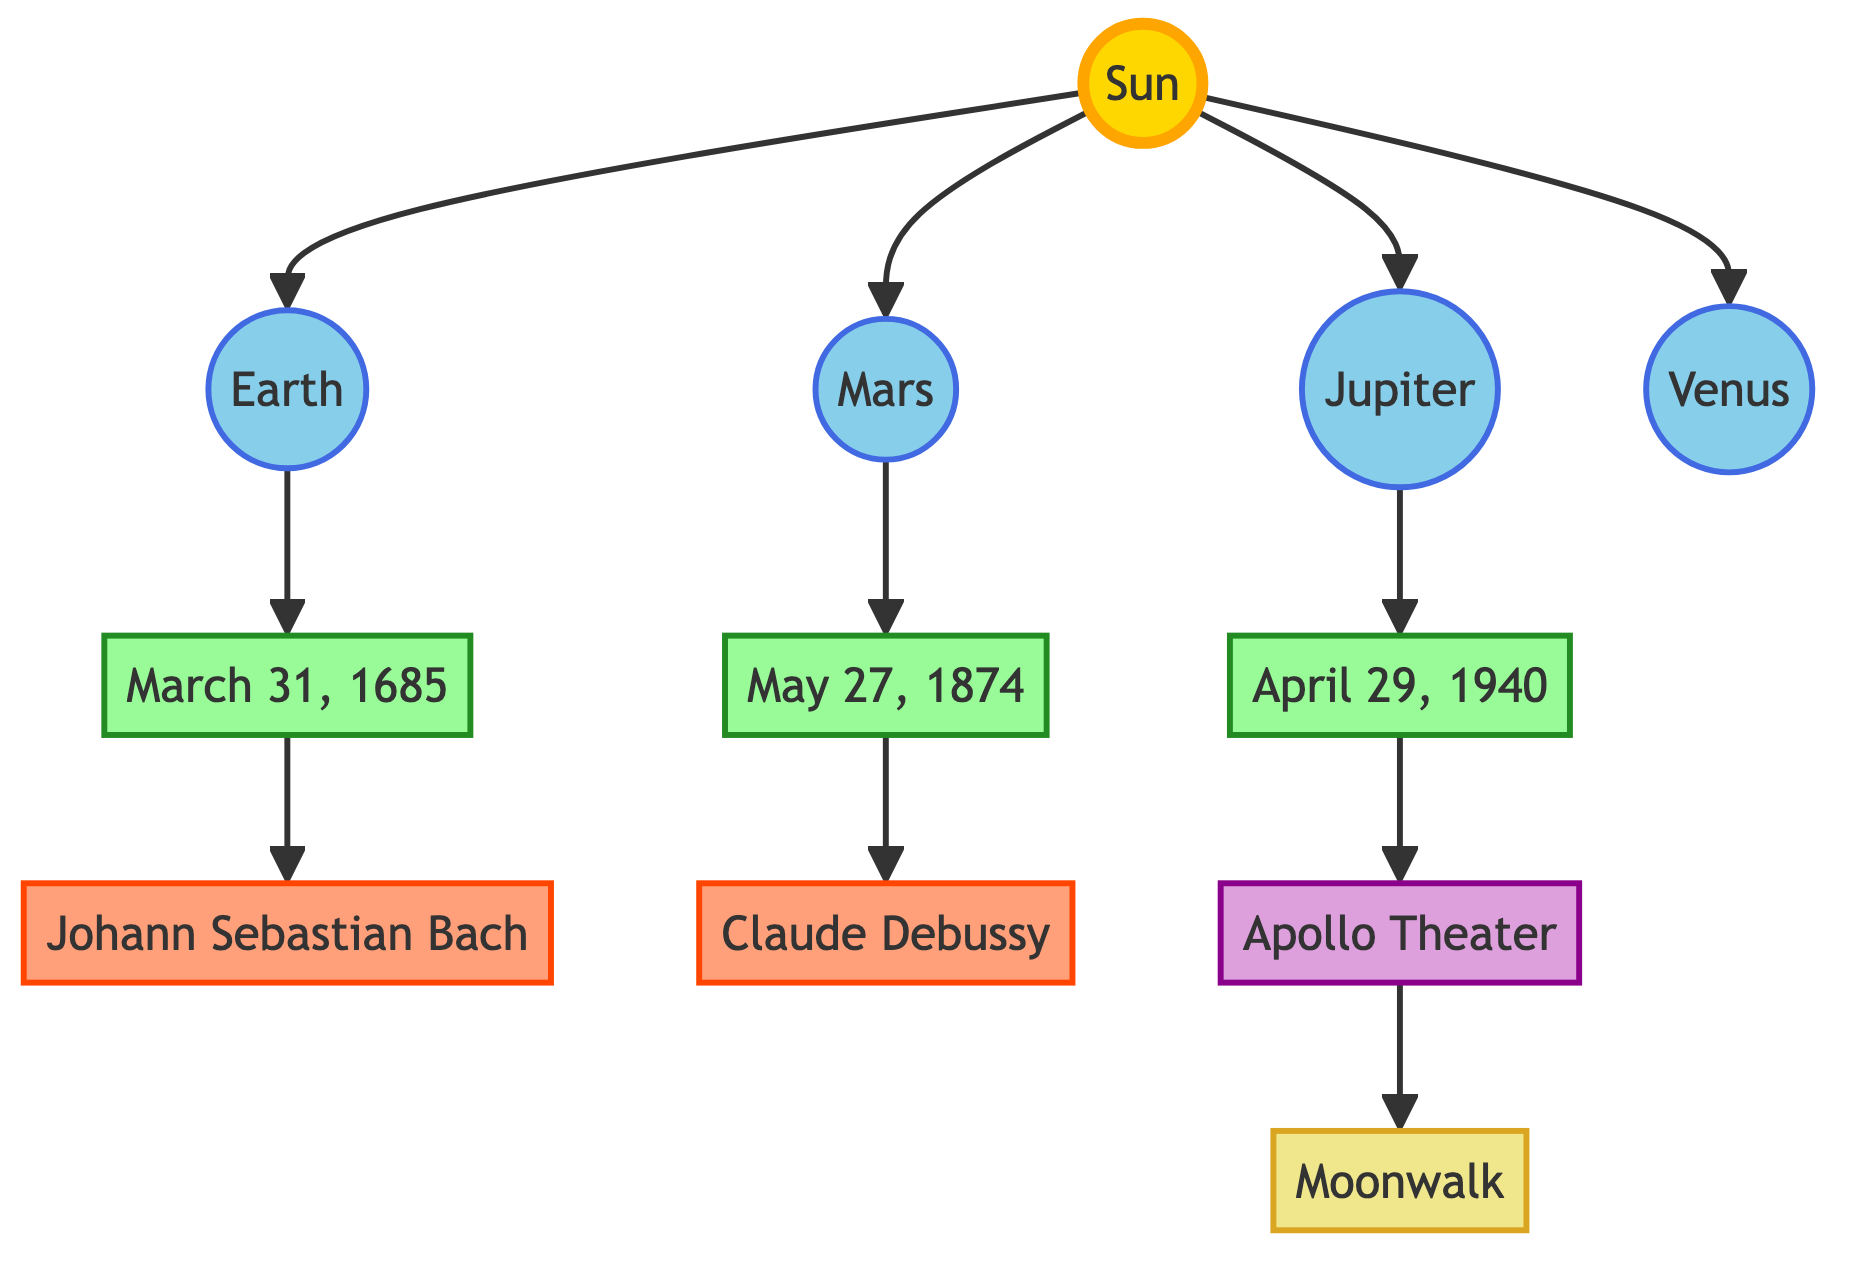What is the creation date of the piece associated with Johann Sebastian Bach? In the diagram, the node connected to Johann Sebastian Bach is linked to the date node labeled "March 31, 1685." This indicates that this is the creation date of the piece related to him.
Answer: March 31, 1685 Which planet is linked to Claude Debussy? The diagram shows that Claude Debussy is connected to the date node "May 27, 1874," which in turn is linked to the planet Mars. Therefore, Mars is the planet associated with Claude Debussy.
Answer: Mars How many musicians are represented in the diagram? The diagram contains two musicians: Johann Sebastian Bach and Claude Debussy. By counting these nodes, we find there are two musicians represented.
Answer: 2 What dance style is linked to the Apollo Theater? Observing the diagram, the Apollo Theater is linked to the dance node labeled "Moonwalk." This indicates that the Moonwalk is the dance style associated with the Apollo Theater.
Answer: Moonwalk Which planet is connected to the creation date of April 29, 1940? The created date "April 29, 1940" is linked to the planet Jupiter in the diagram. This indicates that Jupiter is the planetary position relevant to that date.
Answer: Jupiter What is the relationship between the Sun and the planets? The diagram shows that the Sun is the central star, with direct connections to all listed planets: Earth, Mars, Jupiter, and Venus. This indicates that the planets are all orbiting or linked to the Sun.
Answer: Orbiting What are the two key historical dates depicted in the diagram? The diagram presents three key historical dates which are March 31, 1685; May 27, 1874; and April 29, 1940. Therefore, the two key dates can be listed as any combination of these historical dates.
Answer: March 31, 1685; May 27, 1874 Which musician is associated with the earliest historical date? The earliest date shown is March 31, 1685, which is connected to Johann Sebastian Bach. Thus, he is the musician associated with the earliest date in the diagram.
Answer: Johann Sebastian Bach What color represents the dance style in the diagram? The node representing the dance style "Moonwalk" is styled with a color defined as light khaki, indicated by the class "dance." This denotes the specific visual styling attributed to dance nodes.
Answer: Light khaki 